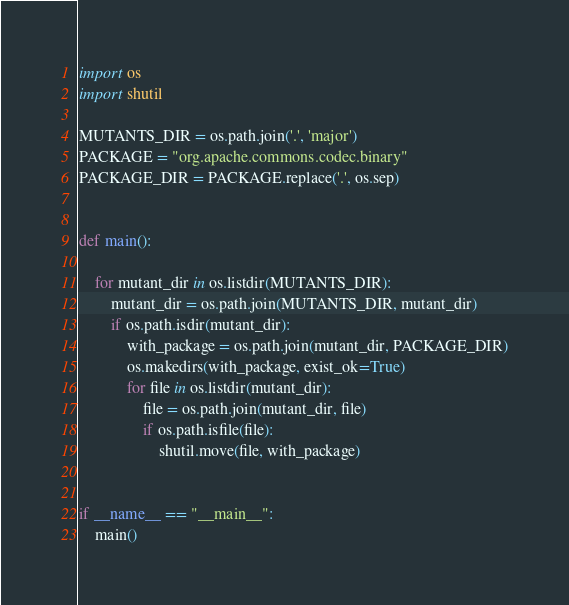Convert code to text. <code><loc_0><loc_0><loc_500><loc_500><_Python_>import os
import shutil

MUTANTS_DIR = os.path.join('.', 'major')
PACKAGE = "org.apache.commons.codec.binary"
PACKAGE_DIR = PACKAGE.replace('.', os.sep)


def main():

    for mutant_dir in os.listdir(MUTANTS_DIR):
        mutant_dir = os.path.join(MUTANTS_DIR, mutant_dir)
        if os.path.isdir(mutant_dir):
            with_package = os.path.join(mutant_dir, PACKAGE_DIR)
            os.makedirs(with_package, exist_ok=True)
            for file in os.listdir(mutant_dir):
                file = os.path.join(mutant_dir, file)
                if os.path.isfile(file):
                    shutil.move(file, with_package)


if __name__ == "__main__":
    main()
</code> 